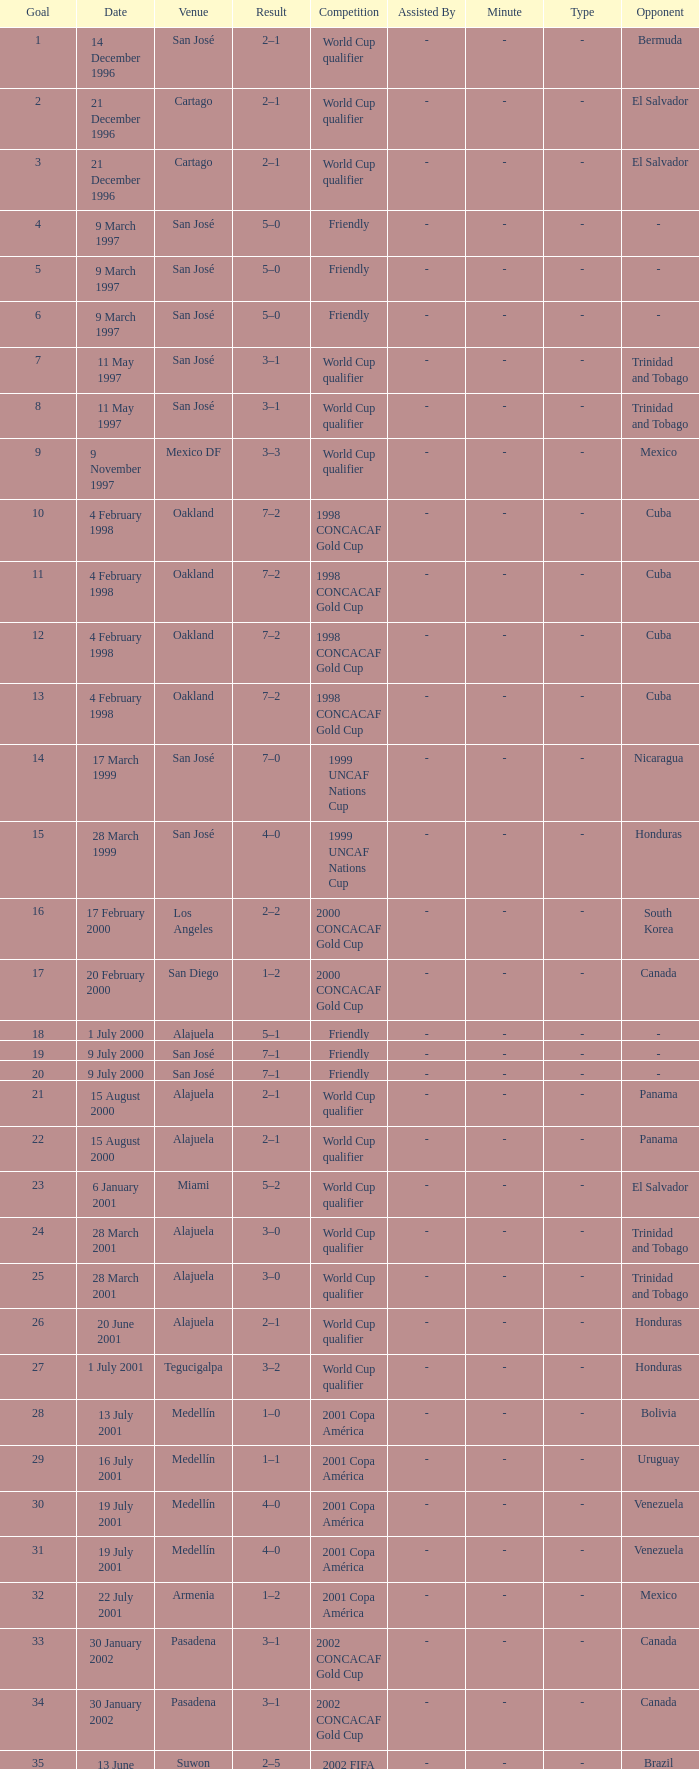What is the result in oakland? 7–2, 7–2, 7–2, 7–2. 